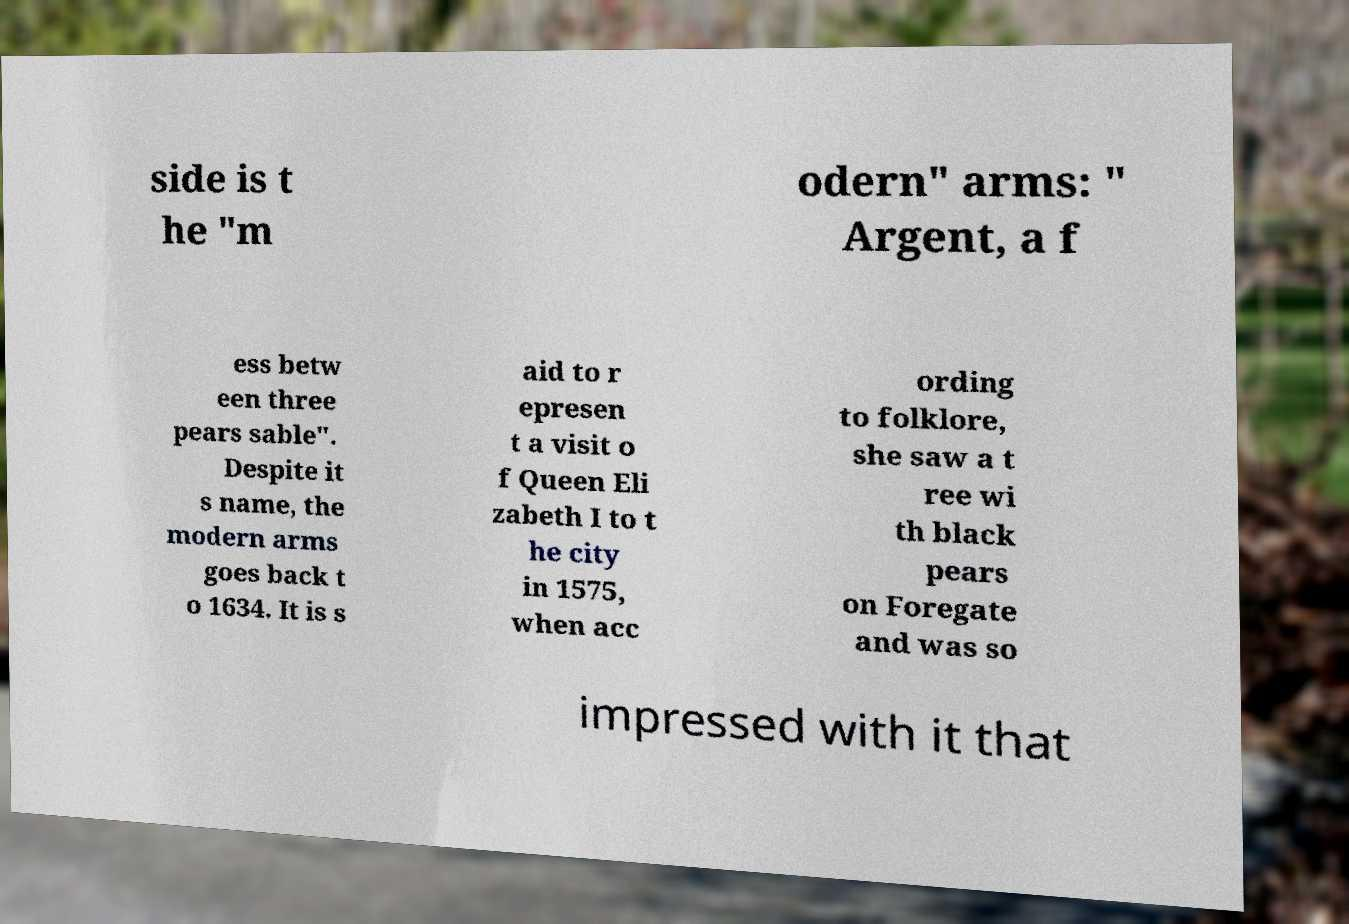Could you assist in decoding the text presented in this image and type it out clearly? side is t he "m odern" arms: " Argent, a f ess betw een three pears sable". Despite it s name, the modern arms goes back t o 1634. It is s aid to r epresen t a visit o f Queen Eli zabeth I to t he city in 1575, when acc ording to folklore, she saw a t ree wi th black pears on Foregate and was so impressed with it that 